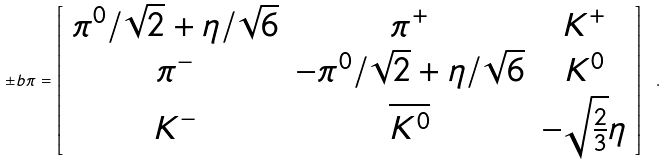<formula> <loc_0><loc_0><loc_500><loc_500>\pm b { \pi } = \left [ \begin{array} { c c c } \pi ^ { 0 } / \sqrt { 2 } + \eta / \sqrt { 6 } & \pi ^ { + } & K ^ { + } \\ \pi ^ { - } & - \pi ^ { 0 } / \sqrt { 2 } + \eta / \sqrt { 6 } & K ^ { 0 } \\ K ^ { - } & \overline { K ^ { 0 } } & - \sqrt { \frac { 2 } { 3 } } \eta \end{array} \right ] \ .</formula> 